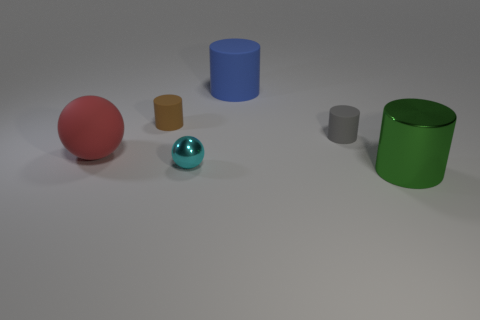How many metal things are behind the green cylinder?
Your answer should be compact. 1. There is a big cylinder that is in front of the large cylinder that is behind the tiny cyan metal object; what is its material?
Offer a very short reply. Metal. The red thing that is the same material as the blue thing is what size?
Make the answer very short. Large. Is there any other thing of the same color as the large shiny thing?
Ensure brevity in your answer.  No. There is a ball right of the brown object; what color is it?
Give a very brief answer. Cyan. Are there any blue matte things that are right of the matte cylinder to the left of the metallic object left of the big metal cylinder?
Keep it short and to the point. Yes. Is the number of objects that are right of the red matte object greater than the number of large brown matte blocks?
Offer a very short reply. Yes. Do the metal thing left of the large green cylinder and the big red rubber thing have the same shape?
Provide a short and direct response. Yes. How many things are either small gray cylinders or big cylinders that are behind the cyan thing?
Your answer should be compact. 2. There is a rubber object that is both on the left side of the metal ball and right of the red object; how big is it?
Ensure brevity in your answer.  Small. 